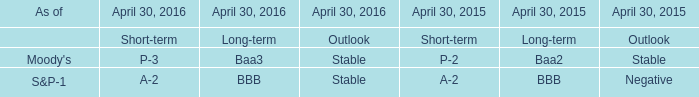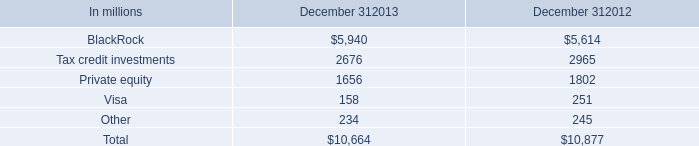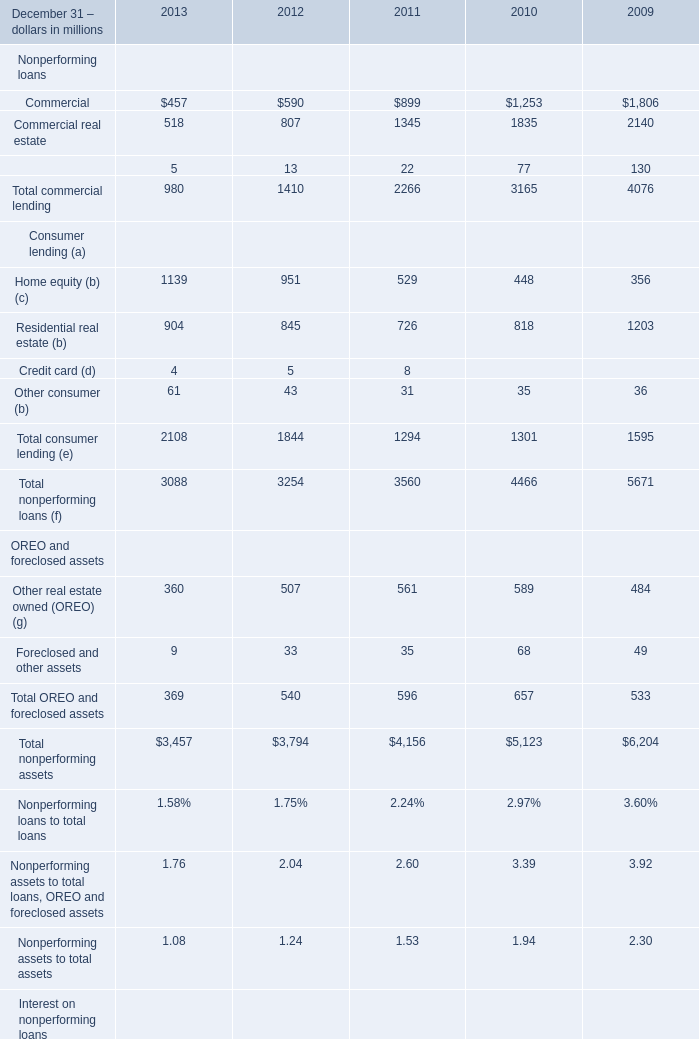What's the sum of all Consumer lending (a) that are greater than 400 in 2013? (in million) 
Computations: (1139 + 904)
Answer: 2043.0. 